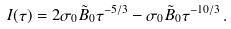<formula> <loc_0><loc_0><loc_500><loc_500>I ( \tau ) = 2 \sigma _ { 0 } \tilde { B } _ { 0 } \tau ^ { - 5 / 3 } - \sigma _ { 0 } \tilde { B } _ { 0 } \tau ^ { - 1 0 / 3 } \, .</formula> 